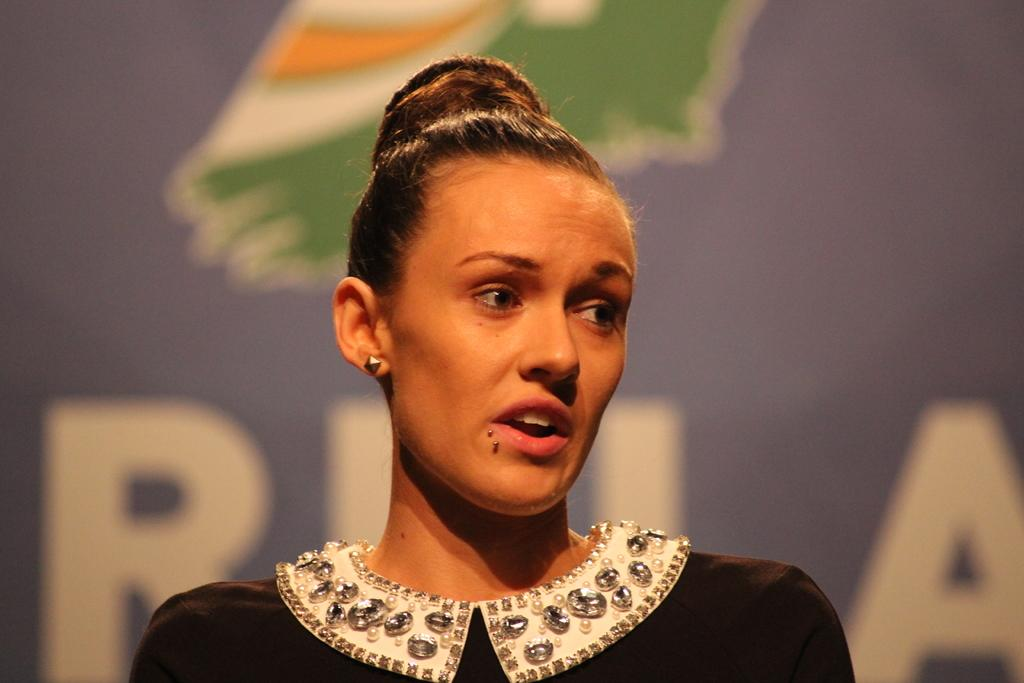Who is present in the image? There is a woman in the image. What is the woman wearing? The woman is wearing a black and white dress. What can be seen in the background of the image? There is a board in the background of the image. What type of cabbage is being used to decorate the woman's hair in the image? There is no cabbage present in the image, nor is it being used to decorate the woman's hair. 